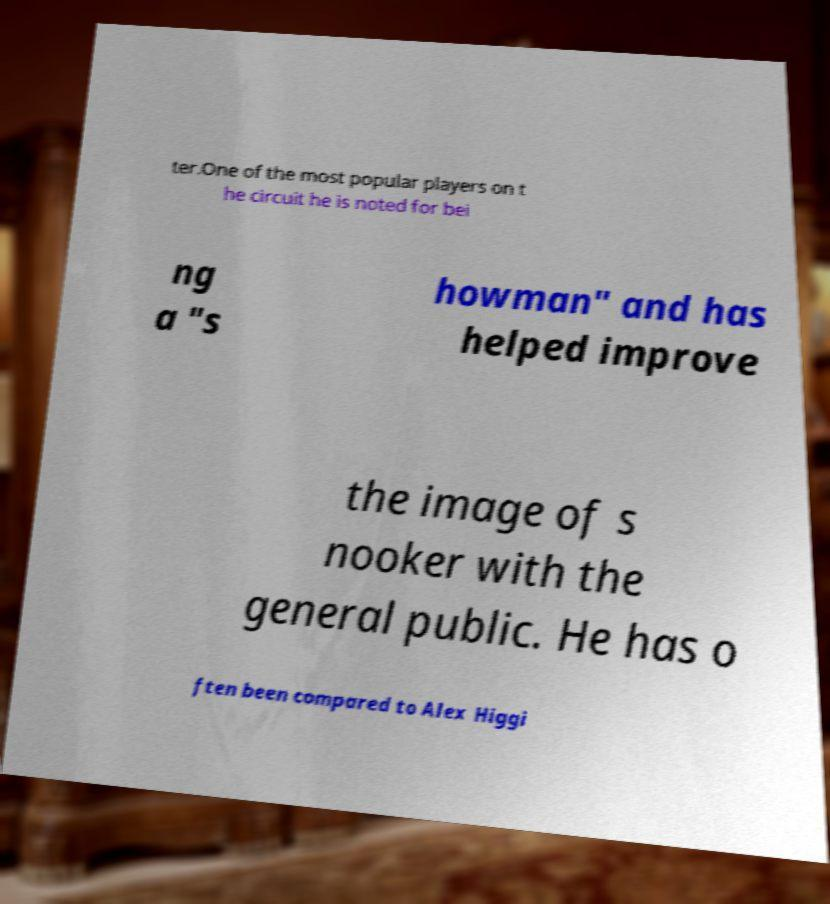Could you assist in decoding the text presented in this image and type it out clearly? ter.One of the most popular players on t he circuit he is noted for bei ng a "s howman" and has helped improve the image of s nooker with the general public. He has o ften been compared to Alex Higgi 